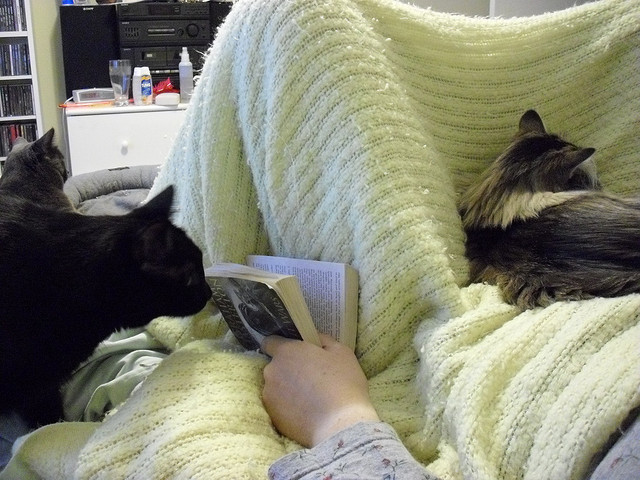How many cats are there? There are three cats in the image, each exhibiting its own demeanor. One appears to be inquisitive, closely inspecting the book, perhaps drawn to the movement of the pages or the curiosity of its human companion's attention. The other two seem comfortably nestled against the cozy yellow blanket, enjoying a moment of relaxation with their human, in what looks like a quiet and calm setting. 